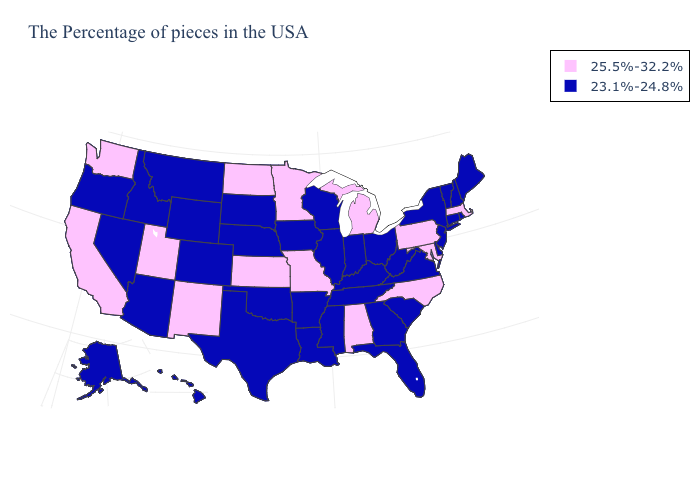What is the value of Illinois?
Concise answer only. 23.1%-24.8%. What is the value of Kansas?
Concise answer only. 25.5%-32.2%. Which states have the lowest value in the Northeast?
Keep it brief. Maine, Rhode Island, New Hampshire, Vermont, Connecticut, New York, New Jersey. What is the value of South Dakota?
Keep it brief. 23.1%-24.8%. Name the states that have a value in the range 25.5%-32.2%?
Write a very short answer. Massachusetts, Maryland, Pennsylvania, North Carolina, Michigan, Alabama, Missouri, Minnesota, Kansas, North Dakota, New Mexico, Utah, California, Washington. Among the states that border Nevada , does Idaho have the highest value?
Give a very brief answer. No. Name the states that have a value in the range 23.1%-24.8%?
Short answer required. Maine, Rhode Island, New Hampshire, Vermont, Connecticut, New York, New Jersey, Delaware, Virginia, South Carolina, West Virginia, Ohio, Florida, Georgia, Kentucky, Indiana, Tennessee, Wisconsin, Illinois, Mississippi, Louisiana, Arkansas, Iowa, Nebraska, Oklahoma, Texas, South Dakota, Wyoming, Colorado, Montana, Arizona, Idaho, Nevada, Oregon, Alaska, Hawaii. What is the value of Vermont?
Give a very brief answer. 23.1%-24.8%. What is the lowest value in the West?
Quick response, please. 23.1%-24.8%. Does California have the lowest value in the USA?
Answer briefly. No. Does New Hampshire have the highest value in the USA?
Write a very short answer. No. Name the states that have a value in the range 23.1%-24.8%?
Keep it brief. Maine, Rhode Island, New Hampshire, Vermont, Connecticut, New York, New Jersey, Delaware, Virginia, South Carolina, West Virginia, Ohio, Florida, Georgia, Kentucky, Indiana, Tennessee, Wisconsin, Illinois, Mississippi, Louisiana, Arkansas, Iowa, Nebraska, Oklahoma, Texas, South Dakota, Wyoming, Colorado, Montana, Arizona, Idaho, Nevada, Oregon, Alaska, Hawaii. What is the value of New Jersey?
Give a very brief answer. 23.1%-24.8%. Does Delaware have the highest value in the USA?
Short answer required. No. 